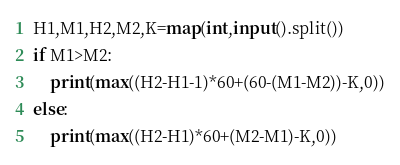<code> <loc_0><loc_0><loc_500><loc_500><_Python_>H1,M1,H2,M2,K=map(int,input().split())
if M1>M2:
    print(max((H2-H1-1)*60+(60-(M1-M2))-K,0))
else:
    print(max((H2-H1)*60+(M2-M1)-K,0))</code> 